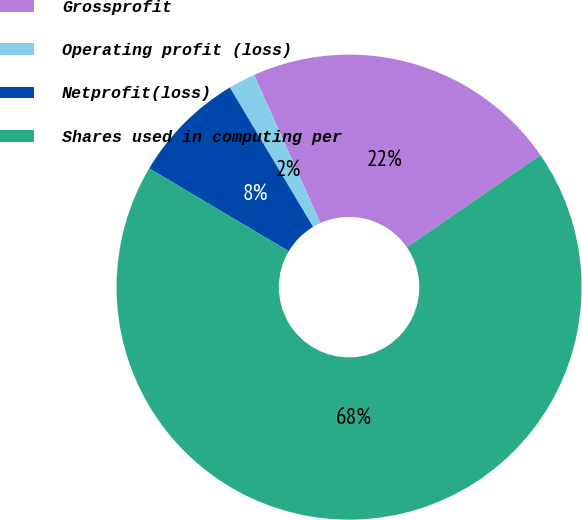<chart> <loc_0><loc_0><loc_500><loc_500><pie_chart><fcel>Grossprofit<fcel>Operating profit (loss)<fcel>Netprofit(loss)<fcel>Shares used in computing per<nl><fcel>22.08%<fcel>1.87%<fcel>7.9%<fcel>68.15%<nl></chart> 